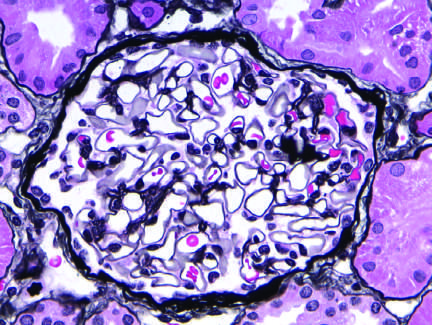what does the silver methenamine-stained glomerulus appear normal with?
Answer the question using a single word or phrase. A delicate basement membrane 